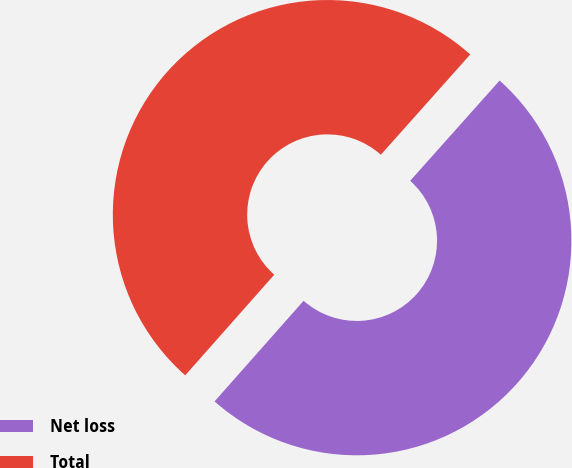Convert chart. <chart><loc_0><loc_0><loc_500><loc_500><pie_chart><fcel>Net loss<fcel>Total<nl><fcel>49.94%<fcel>50.06%<nl></chart> 